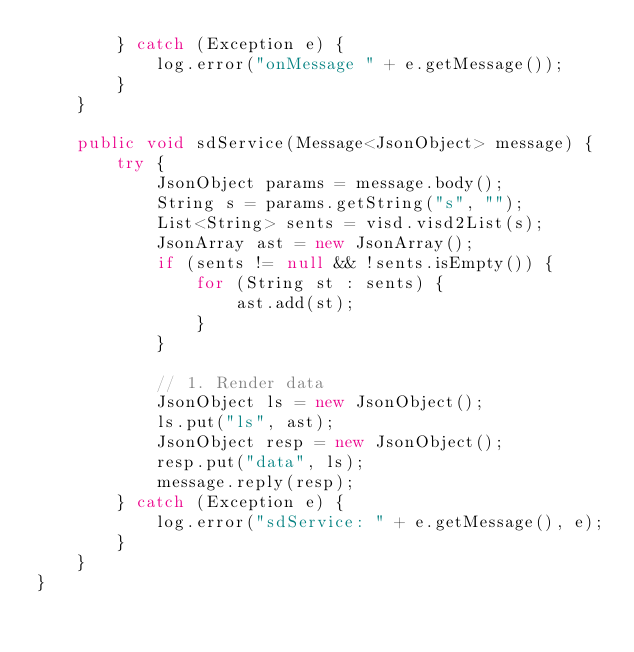<code> <loc_0><loc_0><loc_500><loc_500><_Java_>        } catch (Exception e) {
            log.error("onMessage " + e.getMessage());
        }
    }
    
    public void sdService(Message<JsonObject> message) {
        try {
            JsonObject params = message.body();
            String s = params.getString("s", "");
            List<String> sents = visd.visd2List(s);
            JsonArray ast = new JsonArray();
            if (sents != null && !sents.isEmpty()) {
                for (String st : sents) {
                    ast.add(st);
                }
            }
            
            // 1. Render data
            JsonObject ls = new JsonObject();
            ls.put("ls", ast);
            JsonObject resp = new JsonObject();
            resp.put("data", ls);
            message.reply(resp);
        } catch (Exception e) {
            log.error("sdService: " + e.getMessage(), e);
        }
    }
}
</code> 